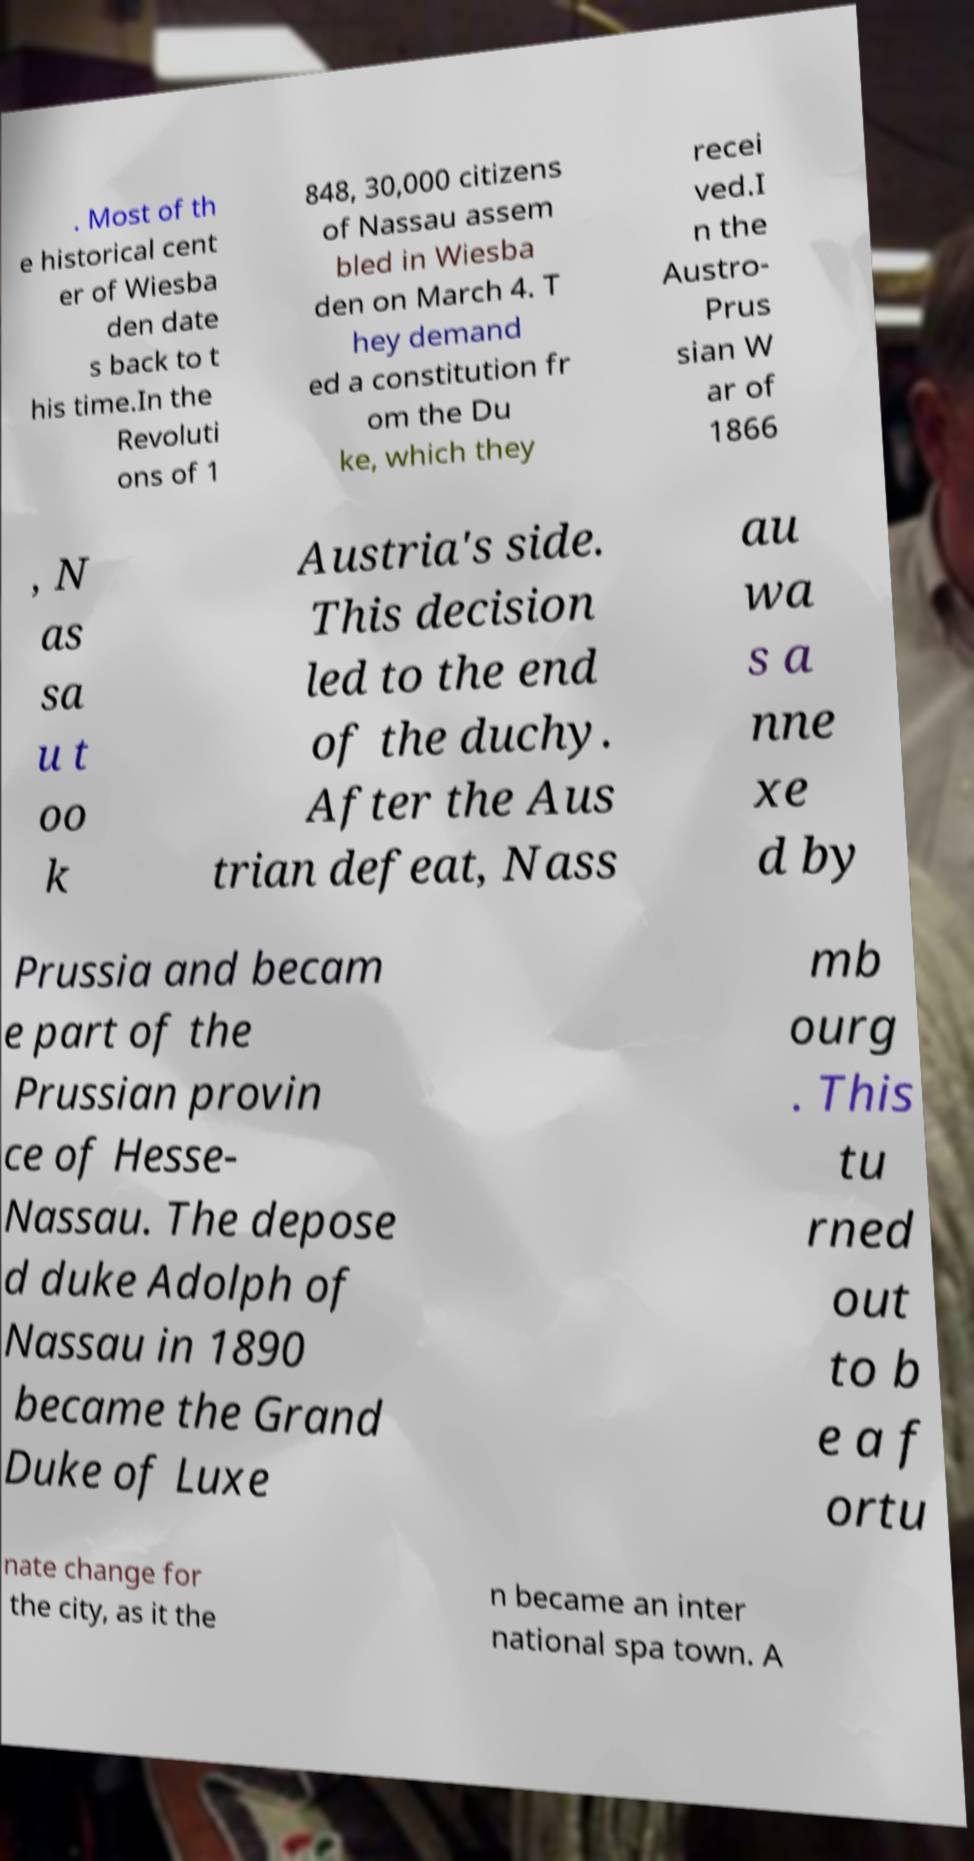Can you read and provide the text displayed in the image?This photo seems to have some interesting text. Can you extract and type it out for me? . Most of th e historical cent er of Wiesba den date s back to t his time.In the Revoluti ons of 1 848, 30,000 citizens of Nassau assem bled in Wiesba den on March 4. T hey demand ed a constitution fr om the Du ke, which they recei ved.I n the Austro- Prus sian W ar of 1866 , N as sa u t oo k Austria's side. This decision led to the end of the duchy. After the Aus trian defeat, Nass au wa s a nne xe d by Prussia and becam e part of the Prussian provin ce of Hesse- Nassau. The depose d duke Adolph of Nassau in 1890 became the Grand Duke of Luxe mb ourg . This tu rned out to b e a f ortu nate change for the city, as it the n became an inter national spa town. A 